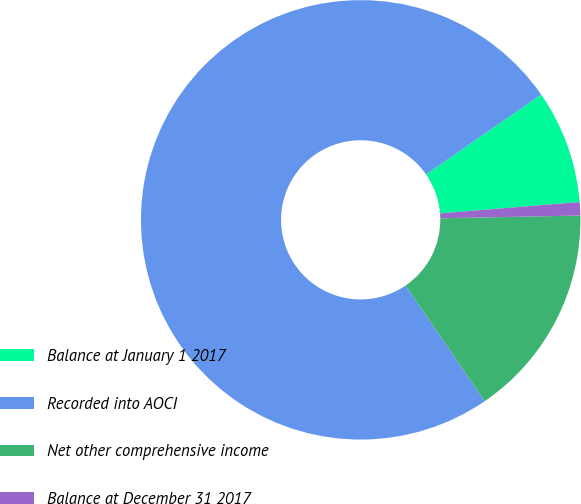Convert chart. <chart><loc_0><loc_0><loc_500><loc_500><pie_chart><fcel>Balance at January 1 2017<fcel>Recorded into AOCI<fcel>Net other comprehensive income<fcel>Balance at December 31 2017<nl><fcel>8.37%<fcel>74.89%<fcel>15.76%<fcel>0.98%<nl></chart> 